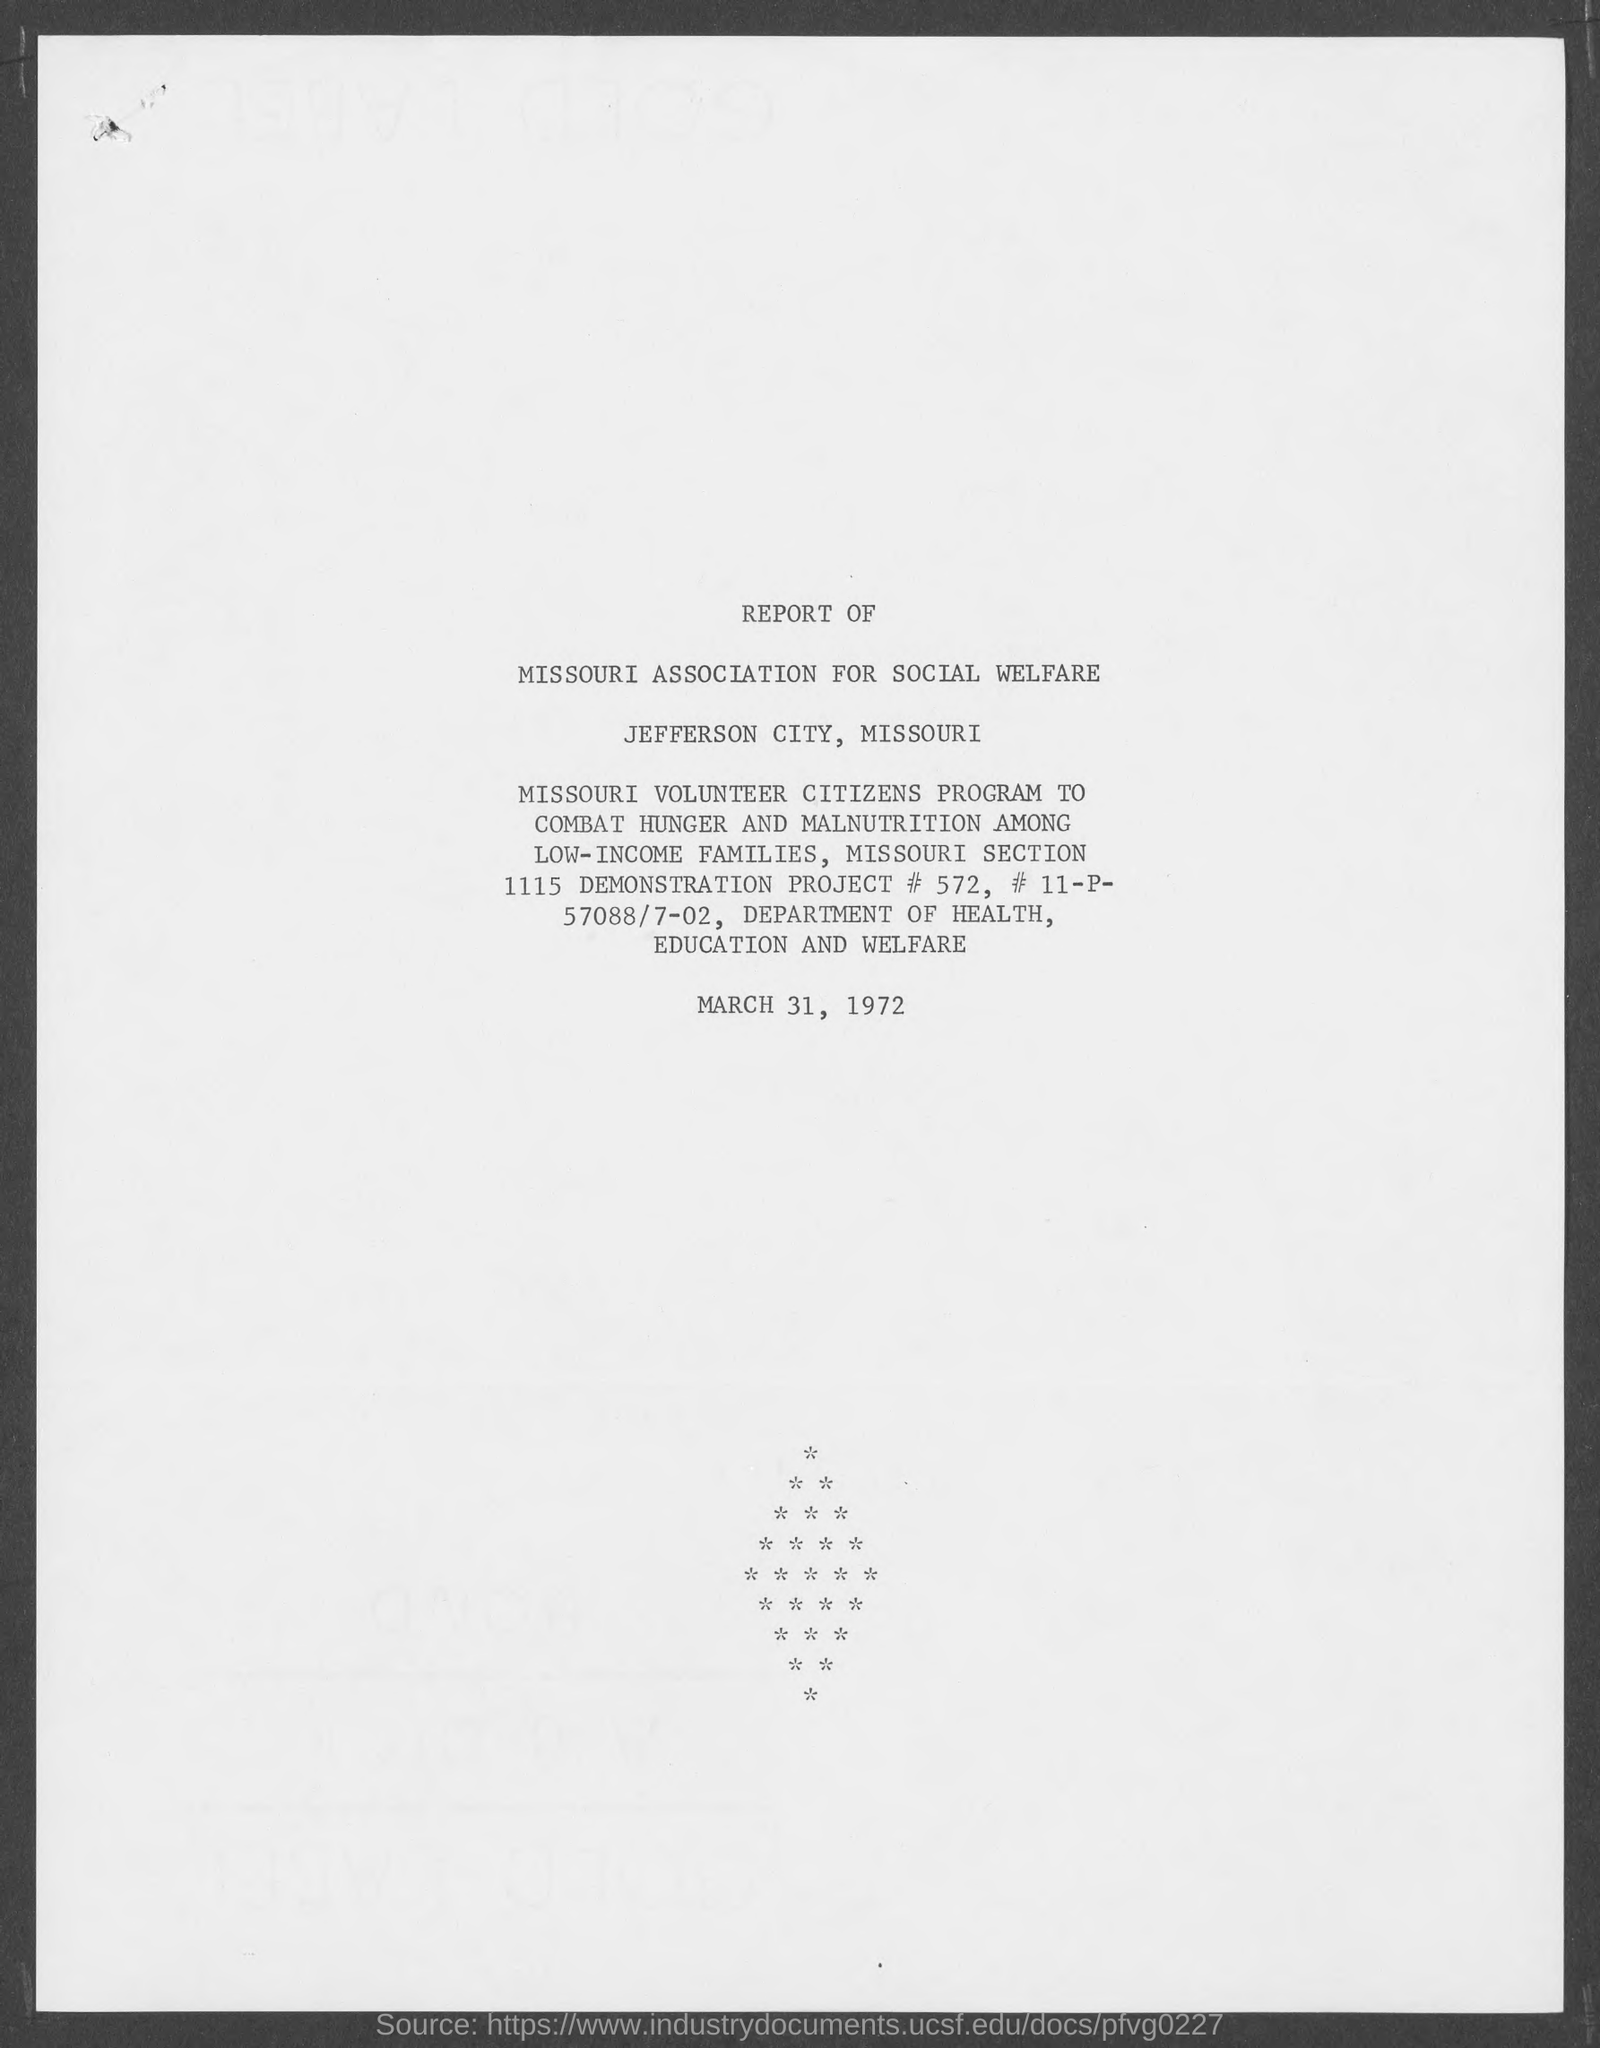Where is "MISSOURI ASSOCIATION FOR SOCIAL WELFARE" located?
Give a very brief answer. JEFFERSON CITY, MISSOURI. What is the date given at the end of the REPORT?
Your answer should be compact. MARCH 31, 1972. 